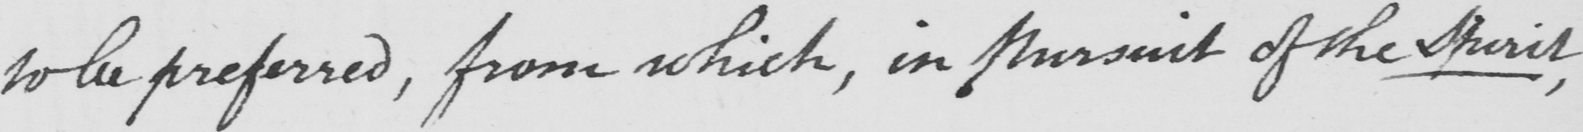Please provide the text content of this handwritten line. to be preferred , from which,in Pursuit of the Spirit , 